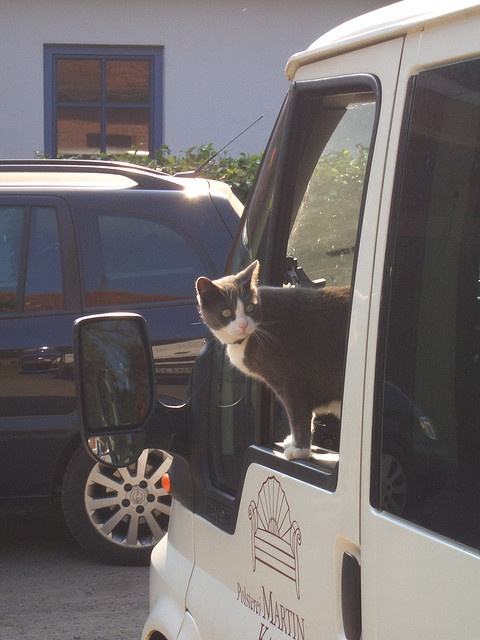Describe the objects in this image and their specific colors. I can see truck in gray, black, and darkgray tones, car in gray, black, and darkgray tones, car in gray, black, and ivory tones, and cat in gray and black tones in this image. 